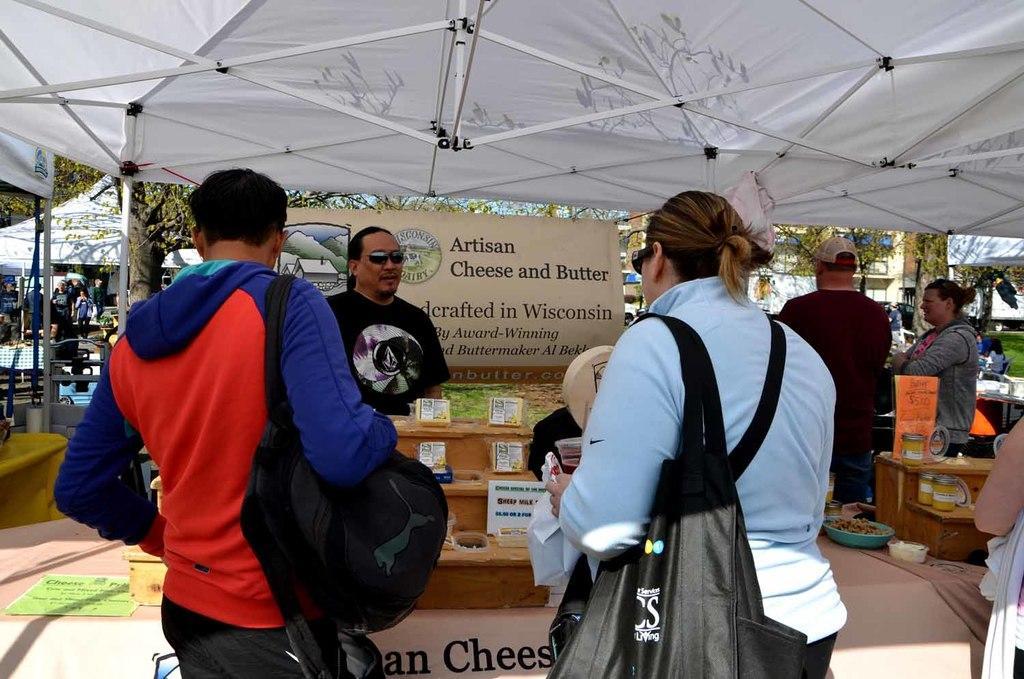Describe this image in one or two sentences. In this image there are some stores and also there are some persons, who are standing and in the stores we could see some boxes, bottles and some other objects. At the bottom there is a table and on the table there is some text, and at the top of the image there is a tent. And in the background there are some tents and some trees and some other objects, and in the center there is one board. On the board there is some text. 